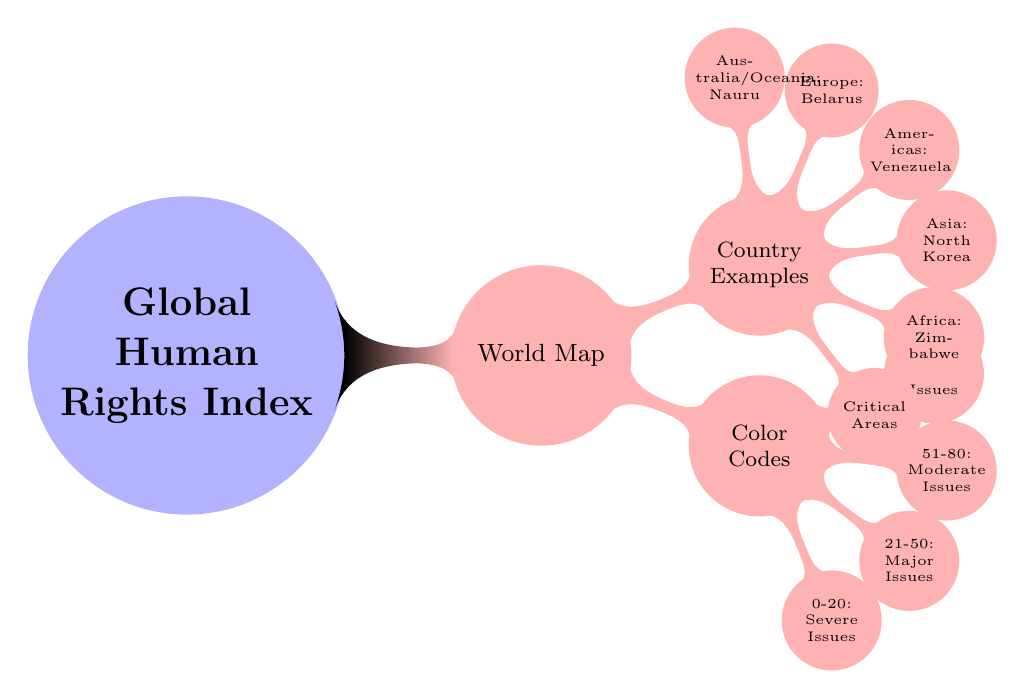What does the color code range 0-20 represent? The color code range 0-20 is associated with "Severe Issues," indicating countries that face the most critical human rights abuses. This label is part of the hierarchy shown in the diagram's color codes.
Answer: Severe Issues Which continent is associated with North Korea in the diagram? North Korea is categorized under Asia, as noted in the country examples section of the diagram. This shows the geographical classification of countries per human rights index.
Answer: Asia How many categories are there in the color codes? The diagram displays four distinct categories under color codes: "Severe Issues," "Major Issues," "Moderate Issues," and "Minor Issues," indicating a structure that allows for classification based on severity.
Answer: Four Which country in the Americas is highlighted for critical human rights issues? Venezuela is indicated as the country in the Americas that is facing critical human rights issues, as it is listed under the country examples in the diagram.
Answer: Venezuela What is the highest score range in the color codes? The highest score range in the color codes is 81-100, which represents "Minor Issues," indicating that countries within this range experience relatively fewer human rights concerns.
Answer: 81-100 Which country is shown as an example from Africa? The diagram lists Zimbabwe as the example country that has critical human rights issues in the African region, providing insight into the situation specific to that continent.
Answer: Zimbabwe Which category includes scores from 21-50? The category that encompasses scores from 21-50 is "Major Issues," representing countries with significant but not the most severe human rights concerns.
Answer: Major Issues How many nodes represent critical areas in the country examples section? There is one node labeled "Critical Areas" under the country examples, indicating a focus point for discussing critical human rights situations without specifying a country.
Answer: One What color represents the "Minor Issues" category? The "Minor Issues" category is represented by a blue color, as indicated by the diagram's color-coded scheme.
Answer: Blue 